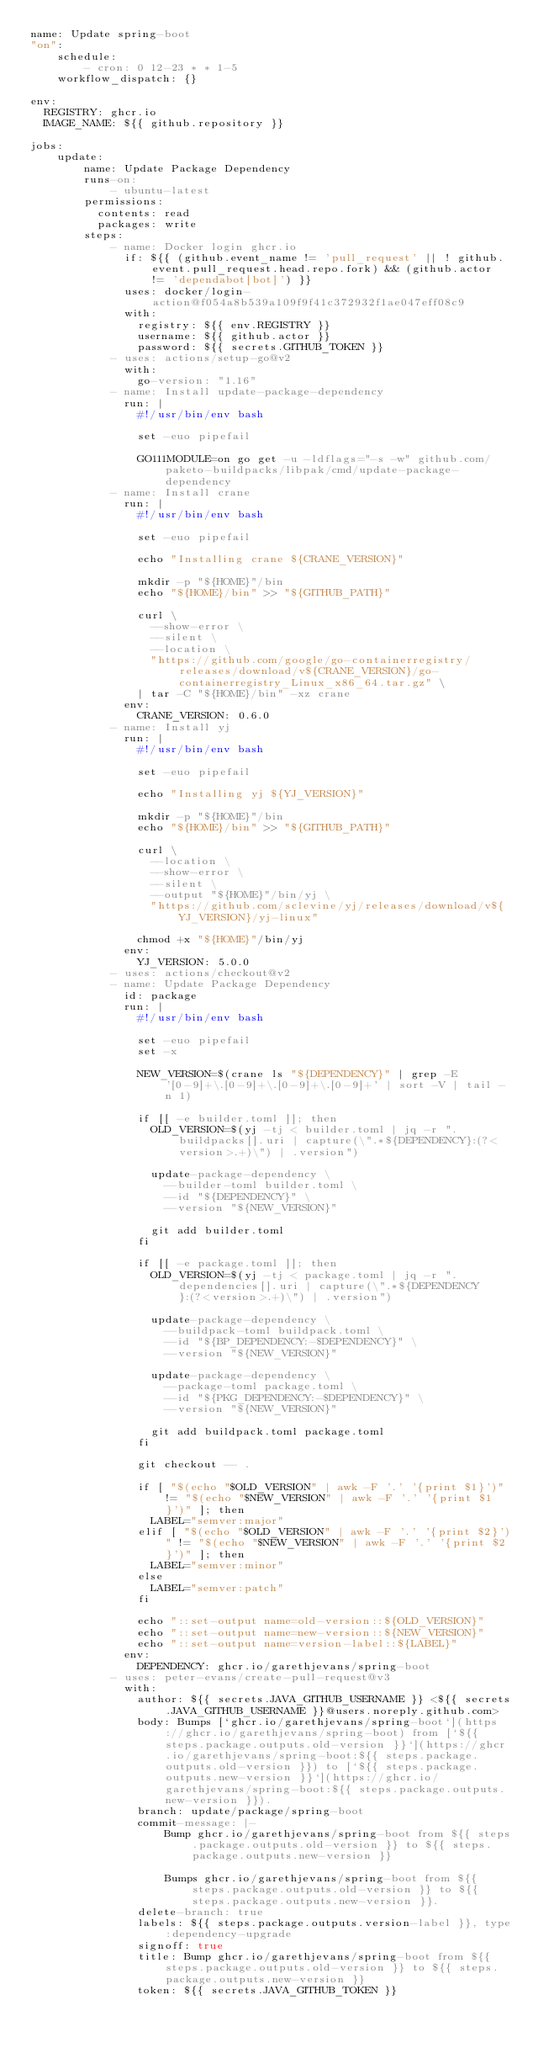Convert code to text. <code><loc_0><loc_0><loc_500><loc_500><_YAML_>name: Update spring-boot
"on":
    schedule:
        - cron: 0 12-23 * * 1-5
    workflow_dispatch: {}

env:
  REGISTRY: ghcr.io
  IMAGE_NAME: ${{ github.repository }}

jobs:
    update:
        name: Update Package Dependency
        runs-on:
            - ubuntu-latest
        permissions:
          contents: read
          packages: write
        steps:
            - name: Docker login ghcr.io
              if: ${{ (github.event_name != 'pull_request' || ! github.event.pull_request.head.repo.fork) && (github.actor != 'dependabot[bot]') }}
              uses: docker/login-action@f054a8b539a109f9f41c372932f1ae047eff08c9
              with:
                registry: ${{ env.REGISTRY }}
                username: ${{ github.actor }}
                password: ${{ secrets.GITHUB_TOKEN }}
            - uses: actions/setup-go@v2
              with:
                go-version: "1.16"
            - name: Install update-package-dependency
              run: |
                #!/usr/bin/env bash

                set -euo pipefail

                GO111MODULE=on go get -u -ldflags="-s -w" github.com/paketo-buildpacks/libpak/cmd/update-package-dependency
            - name: Install crane
              run: |
                #!/usr/bin/env bash

                set -euo pipefail

                echo "Installing crane ${CRANE_VERSION}"

                mkdir -p "${HOME}"/bin
                echo "${HOME}/bin" >> "${GITHUB_PATH}"

                curl \
                  --show-error \
                  --silent \
                  --location \
                  "https://github.com/google/go-containerregistry/releases/download/v${CRANE_VERSION}/go-containerregistry_Linux_x86_64.tar.gz" \
                | tar -C "${HOME}/bin" -xz crane
              env:
                CRANE_VERSION: 0.6.0
            - name: Install yj
              run: |
                #!/usr/bin/env bash

                set -euo pipefail

                echo "Installing yj ${YJ_VERSION}"

                mkdir -p "${HOME}"/bin
                echo "${HOME}/bin" >> "${GITHUB_PATH}"

                curl \
                  --location \
                  --show-error \
                  --silent \
                  --output "${HOME}"/bin/yj \
                  "https://github.com/sclevine/yj/releases/download/v${YJ_VERSION}/yj-linux"

                chmod +x "${HOME}"/bin/yj
              env:
                YJ_VERSION: 5.0.0
            - uses: actions/checkout@v2
            - name: Update Package Dependency
              id: package
              run: |
                #!/usr/bin/env bash

                set -euo pipefail
                set -x

                NEW_VERSION=$(crane ls "${DEPENDENCY}" | grep -E '[0-9]+\.[0-9]+\.[0-9]+\.[0-9]+' | sort -V | tail -n 1)

                if [[ -e builder.toml ]]; then
                  OLD_VERSION=$(yj -tj < builder.toml | jq -r ".buildpacks[].uri | capture(\".*${DEPENDENCY}:(?<version>.+)\") | .version")

                  update-package-dependency \
                    --builder-toml builder.toml \
                    --id "${DEPENDENCY}" \
                    --version "${NEW_VERSION}"

                  git add builder.toml
                fi

                if [[ -e package.toml ]]; then
                  OLD_VERSION=$(yj -tj < package.toml | jq -r ".dependencies[].uri | capture(\".*${DEPENDENCY}:(?<version>.+)\") | .version")

                  update-package-dependency \
                    --buildpack-toml buildpack.toml \
                    --id "${BP_DEPENDENCY:-$DEPENDENCY}" \
                    --version "${NEW_VERSION}"

                  update-package-dependency \
                    --package-toml package.toml \
                    --id "${PKG_DEPENDENCY:-$DEPENDENCY}" \
                    --version "${NEW_VERSION}"

                  git add buildpack.toml package.toml
                fi

                git checkout -- .

                if [ "$(echo "$OLD_VERSION" | awk -F '.' '{print $1}')" != "$(echo "$NEW_VERSION" | awk -F '.' '{print $1}')" ]; then
                  LABEL="semver:major"
                elif [ "$(echo "$OLD_VERSION" | awk -F '.' '{print $2}')" != "$(echo "$NEW_VERSION" | awk -F '.' '{print $2}')" ]; then
                  LABEL="semver:minor"
                else
                  LABEL="semver:patch"
                fi

                echo "::set-output name=old-version::${OLD_VERSION}"
                echo "::set-output name=new-version::${NEW_VERSION}"
                echo "::set-output name=version-label::${LABEL}"
              env:
                DEPENDENCY: ghcr.io/garethjevans/spring-boot
            - uses: peter-evans/create-pull-request@v3
              with:
                author: ${{ secrets.JAVA_GITHUB_USERNAME }} <${{ secrets.JAVA_GITHUB_USERNAME }}@users.noreply.github.com>
                body: Bumps [`ghcr.io/garethjevans/spring-boot`](https://ghcr.io/garethjevans/spring-boot) from [`${{ steps.package.outputs.old-version }}`](https://ghcr.io/garethjevans/spring-boot:${{ steps.package.outputs.old-version }}) to [`${{ steps.package.outputs.new-version }}`](https://ghcr.io/garethjevans/spring-boot:${{ steps.package.outputs.new-version }}).
                branch: update/package/spring-boot
                commit-message: |-
                    Bump ghcr.io/garethjevans/spring-boot from ${{ steps.package.outputs.old-version }} to ${{ steps.package.outputs.new-version }}

                    Bumps ghcr.io/garethjevans/spring-boot from ${{ steps.package.outputs.old-version }} to ${{ steps.package.outputs.new-version }}.
                delete-branch: true
                labels: ${{ steps.package.outputs.version-label }}, type:dependency-upgrade
                signoff: true
                title: Bump ghcr.io/garethjevans/spring-boot from ${{ steps.package.outputs.old-version }} to ${{ steps.package.outputs.new-version }}
                token: ${{ secrets.JAVA_GITHUB_TOKEN }}
</code> 